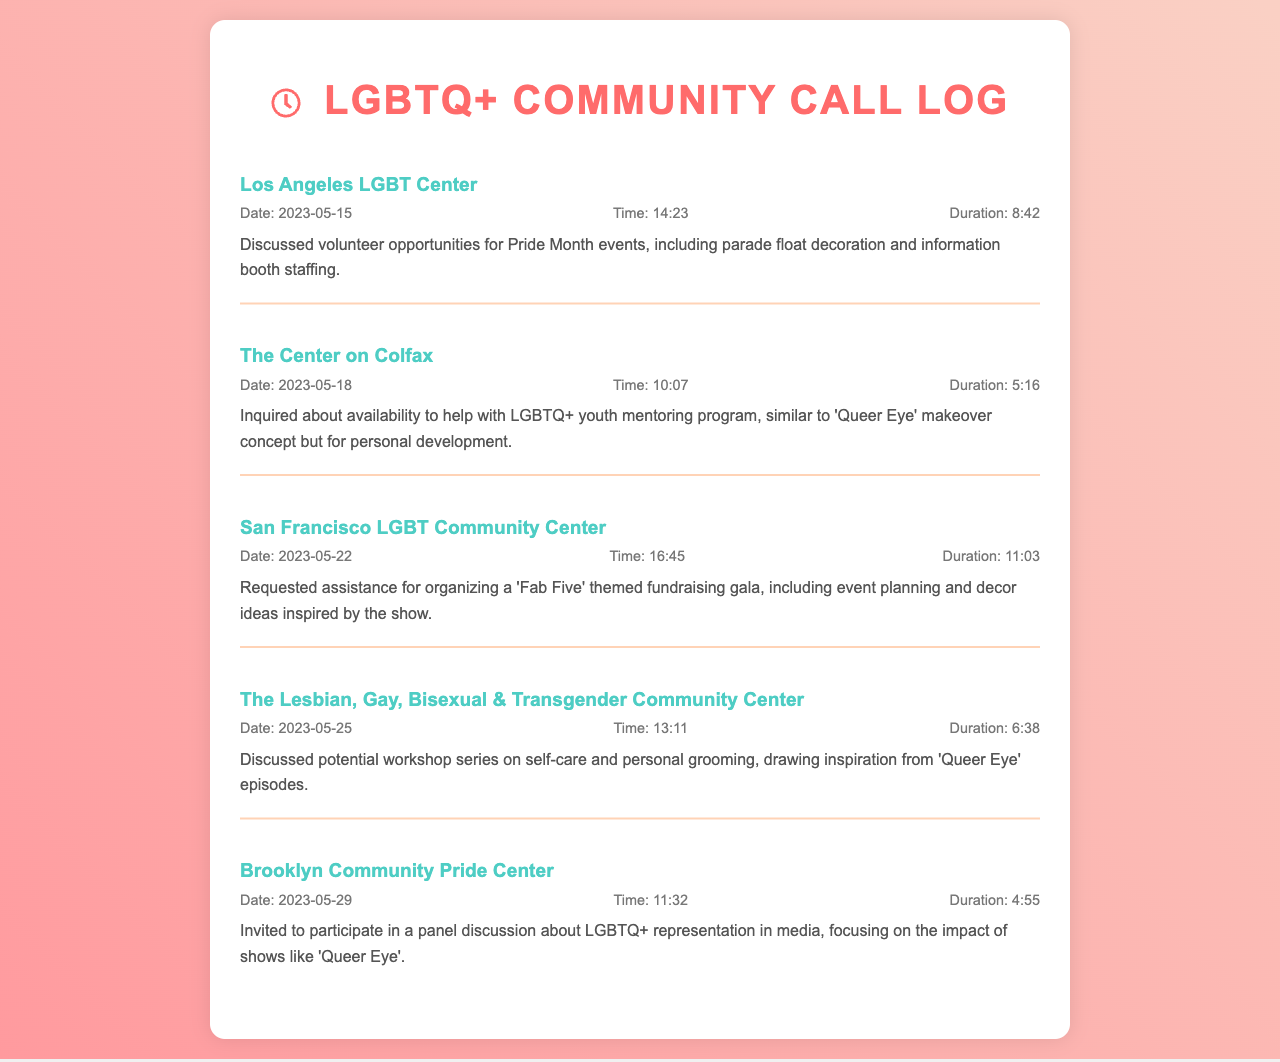What is the name of the first caller? The first caller listed in the document is the Los Angeles LGBT Center.
Answer: Los Angeles LGBT Center What was the main topic of the call on May 18? The call on May 18 involved an inquiry about helping with an LGBTQ+ youth mentoring program.
Answer: LGBTQ+ youth mentoring program How long was the call with the San Francisco LGBT Community Center? The call lasted for 11 minutes and 03 seconds.
Answer: 11:03 Which community center discussed a workshop series inspired by "Queer Eye"? The Lesbian, Gay, Bisexual & Transgender Community Center talked about the workshop series.
Answer: The Lesbian, Gay, Bisexual & Transgender Community Center What is the date of the last call recorded? The last call recorded in the document was on May 29, 2023.
Answer: 2023-05-29 What type of event was the San Francisco LGBT Community Center organizing? They were organizing a 'Fab Five' themed fundraising gala.
Answer: 'Fab Five' themed fundraising gala How many calls were made to discuss volunteer opportunities? There were five calls made regarding volunteer opportunities.
Answer: Five What specific event did the Los Angeles LGBT Center focus on during their call? They focused on Pride Month events.
Answer: Pride Month events What was the duration of the call with the Brooklyn Community Pride Center? The duration of that call was 4 minutes and 55 seconds.
Answer: 4:55 